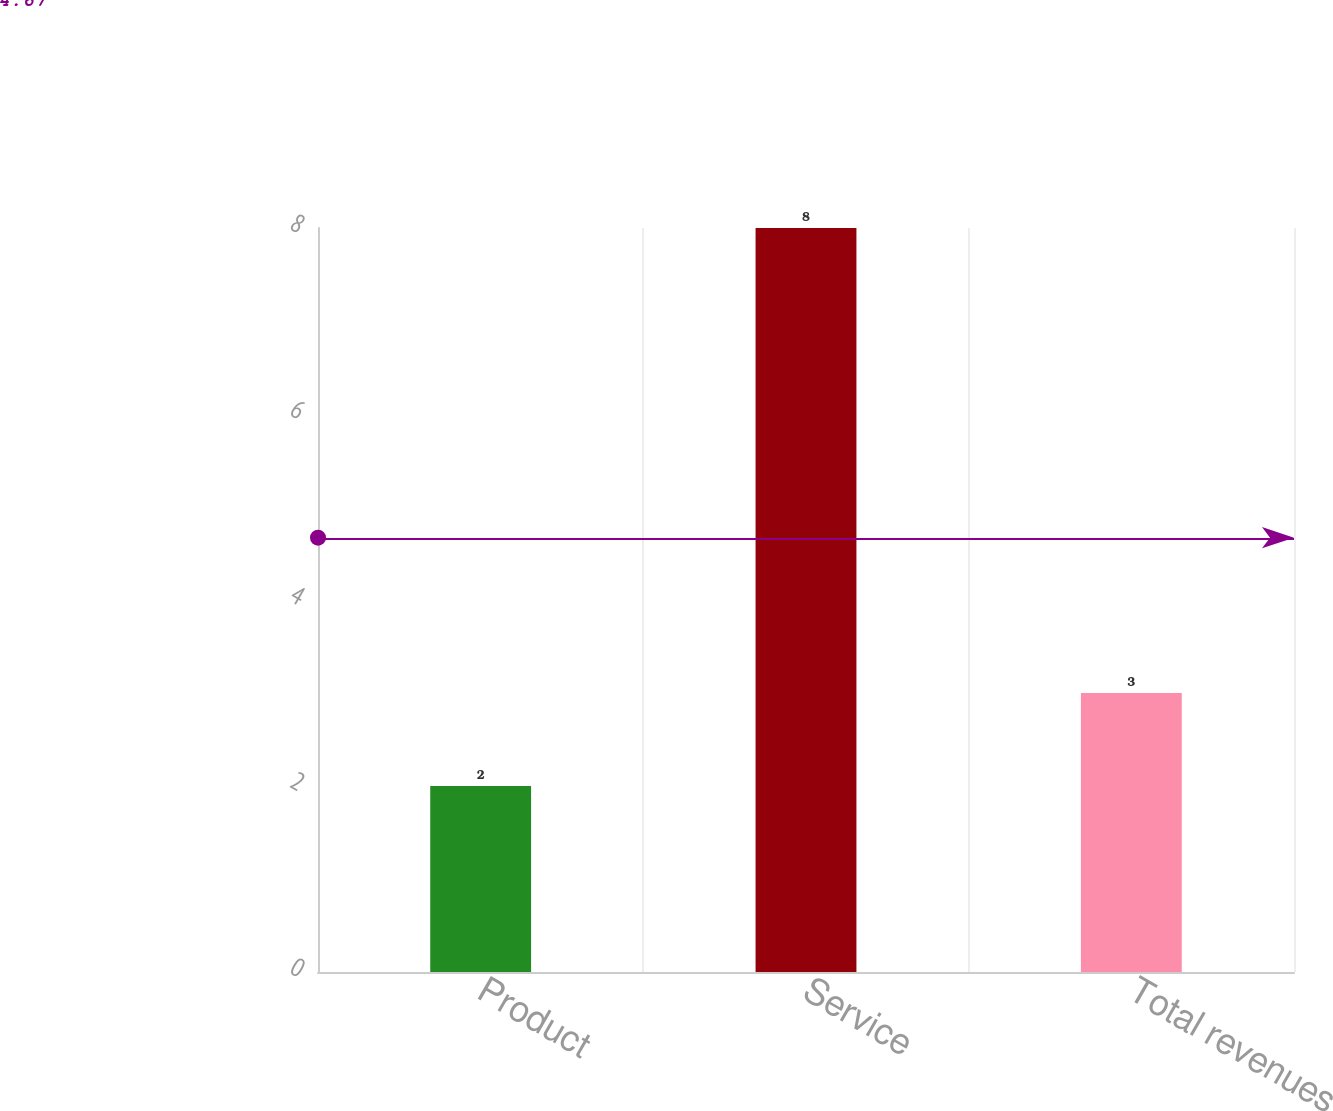<chart> <loc_0><loc_0><loc_500><loc_500><bar_chart><fcel>Product<fcel>Service<fcel>Total revenues<nl><fcel>2<fcel>8<fcel>3<nl></chart> 